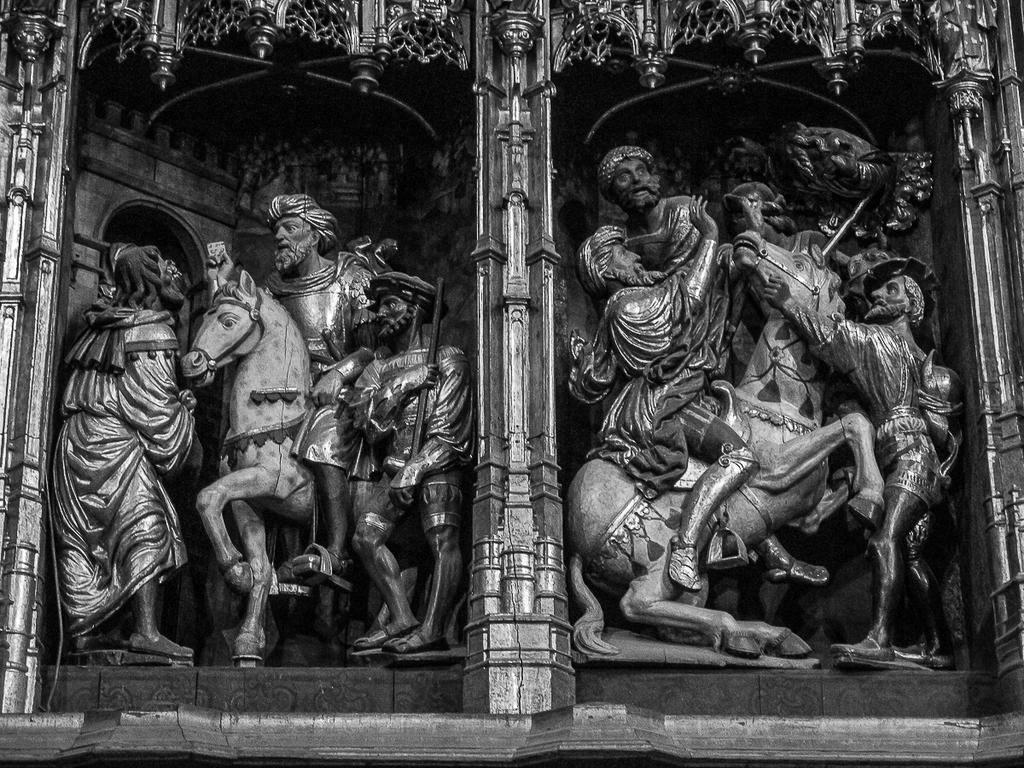What type of art is featured in the image? The image contains sculptures. What year is depicted in the sculpture? There is no specific year depicted in the sculpture; it is a static art piece. 